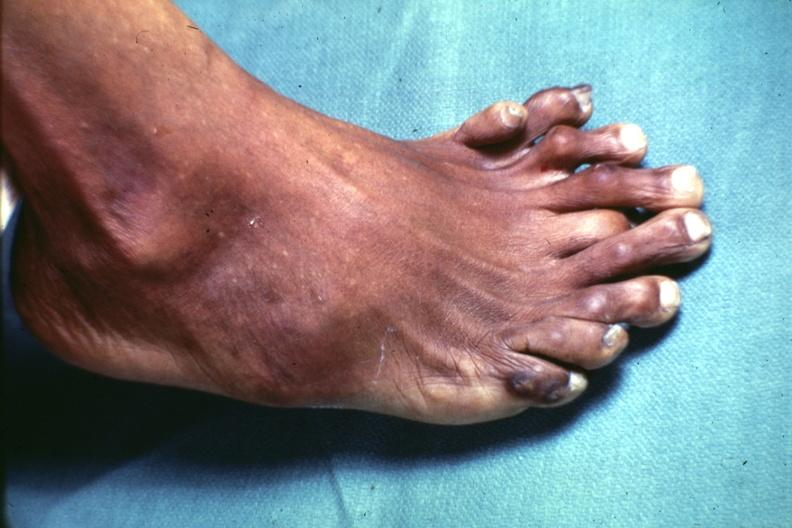what is present?
Answer the question using a single word or phrase. Supernumerary digits 